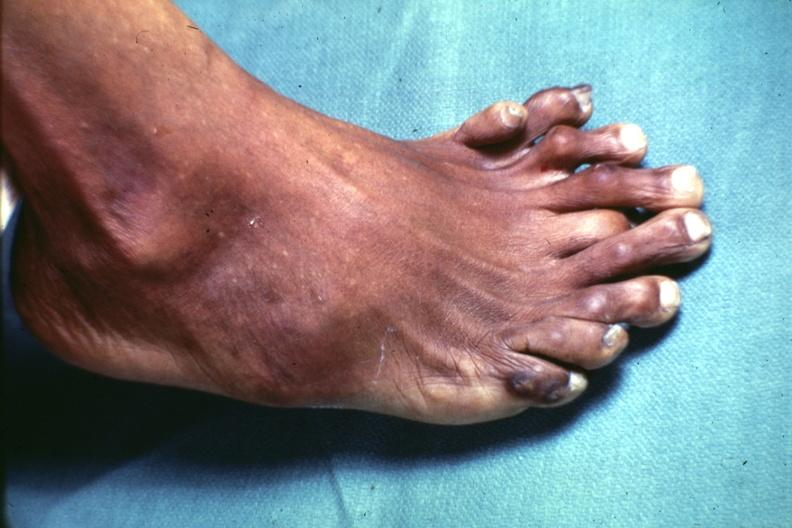what is present?
Answer the question using a single word or phrase. Supernumerary digits 